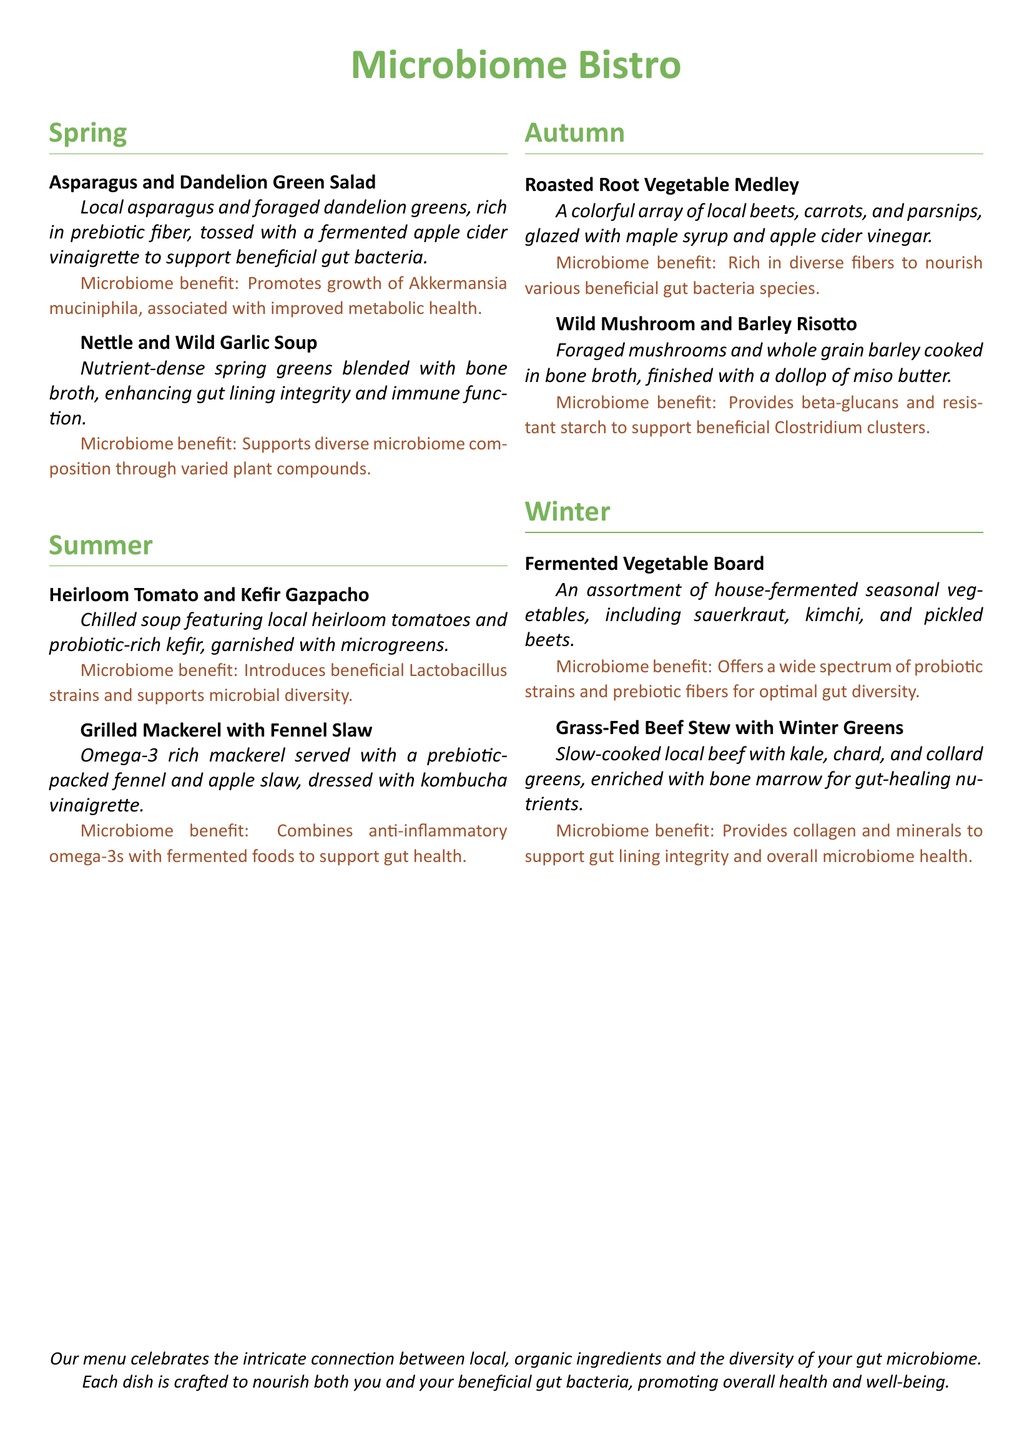What is the name of the restaurant? The restaurant is titled "Microbiome Bistro," which is prominently displayed at the top of the document.
Answer: Microbiome Bistro What season features the Nettle and Wild Garlic Soup? The Nettle and Wild Garlic Soup is listed under the "Spring" section of the menu.
Answer: Spring Which dish includes kefir? The dish featuring kefir is the "Heirloom Tomato and Kefir Gazpacho."
Answer: Heirloom Tomato and Kefir Gazpacho What type of greens are used in the Grass-Fed Beef Stew? The Grass-Fed Beef Stew contains kale, chard, and collard greens, as mentioned in the description.
Answer: Kale, chard, and collard greens What benefit is associated with the Asparagus and Dandelion Green Salad? The microbiome benefit stated for this dish is the promotion of Akkermansia muciniphila, which is linked to metabolic health.
Answer: Promotes growth of Akkermansia muciniphila Which dish is noted for supporting flora diversity through varied plant compounds? The Nettle and Wild Garlic Soup is noted for this microbiome benefit.
Answer: Nettle and Wild Garlic Soup How is the vegetable board characterized in terms of preparation? The vegetable board is described as an assortment of house-fermented seasonal vegetables.
Answer: House-fermented seasonal vegetables What key ingredient enriches the Grass-Fed Beef Stew? Bone marrow is mentioned as the key ingredient that enriches the Beef Stew.
Answer: Bone marrow What type of broth is used in the Wild Mushroom and Barley Risotto? The risotto is cooked in bone broth, which is part of its preparation.
Answer: Bone broth 